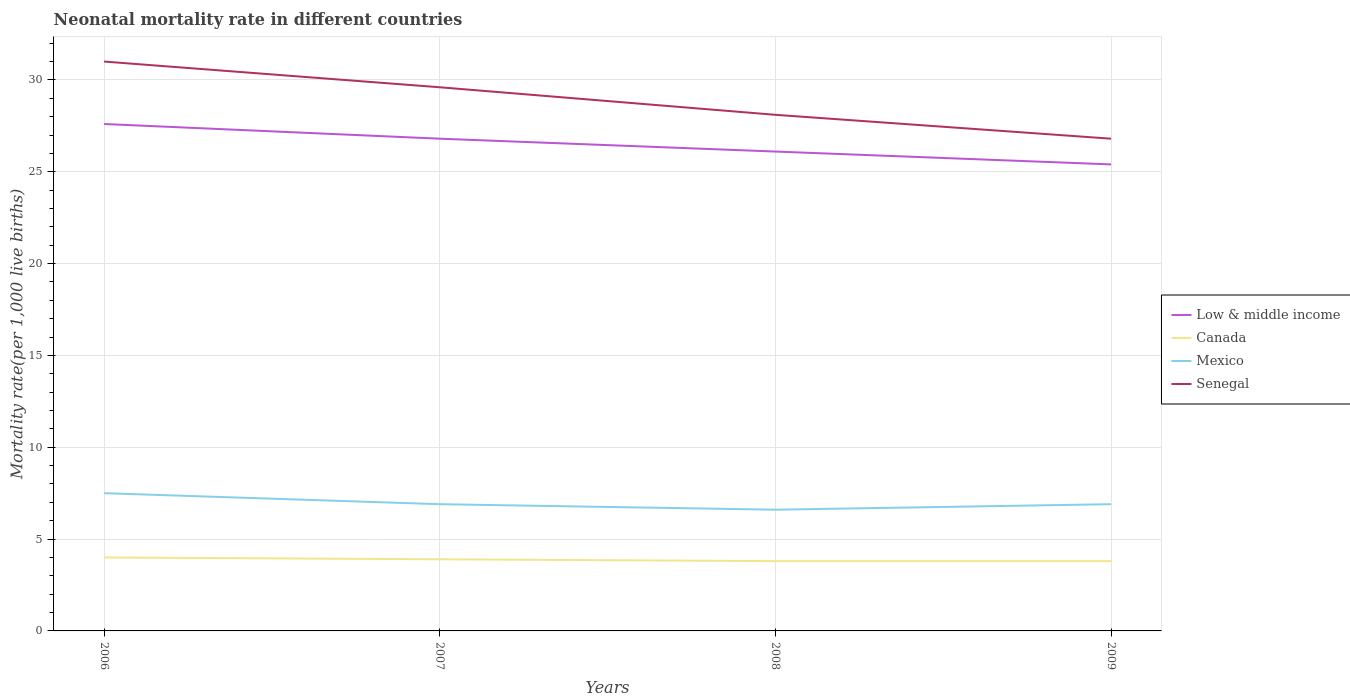Does the line corresponding to Canada intersect with the line corresponding to Senegal?
Provide a short and direct response. No. Across all years, what is the maximum neonatal mortality rate in Senegal?
Provide a short and direct response. 26.8. In which year was the neonatal mortality rate in Canada maximum?
Provide a succinct answer. 2008. What is the total neonatal mortality rate in Mexico in the graph?
Provide a succinct answer. 0.6. What is the difference between the highest and the second highest neonatal mortality rate in Canada?
Offer a terse response. 0.2. What is the difference between the highest and the lowest neonatal mortality rate in Mexico?
Provide a short and direct response. 1. How many years are there in the graph?
Keep it short and to the point. 4. What is the difference between two consecutive major ticks on the Y-axis?
Provide a short and direct response. 5. Does the graph contain any zero values?
Provide a succinct answer. No. How many legend labels are there?
Offer a terse response. 4. What is the title of the graph?
Offer a terse response. Neonatal mortality rate in different countries. Does "Kuwait" appear as one of the legend labels in the graph?
Ensure brevity in your answer.  No. What is the label or title of the X-axis?
Make the answer very short. Years. What is the label or title of the Y-axis?
Provide a short and direct response. Mortality rate(per 1,0 live births). What is the Mortality rate(per 1,000 live births) in Low & middle income in 2006?
Keep it short and to the point. 27.6. What is the Mortality rate(per 1,000 live births) of Mexico in 2006?
Give a very brief answer. 7.5. What is the Mortality rate(per 1,000 live births) of Senegal in 2006?
Provide a succinct answer. 31. What is the Mortality rate(per 1,000 live births) of Low & middle income in 2007?
Make the answer very short. 26.8. What is the Mortality rate(per 1,000 live births) of Senegal in 2007?
Your answer should be very brief. 29.6. What is the Mortality rate(per 1,000 live births) of Low & middle income in 2008?
Keep it short and to the point. 26.1. What is the Mortality rate(per 1,000 live births) in Canada in 2008?
Offer a very short reply. 3.8. What is the Mortality rate(per 1,000 live births) of Senegal in 2008?
Your answer should be very brief. 28.1. What is the Mortality rate(per 1,000 live births) of Low & middle income in 2009?
Make the answer very short. 25.4. What is the Mortality rate(per 1,000 live births) of Mexico in 2009?
Provide a short and direct response. 6.9. What is the Mortality rate(per 1,000 live births) in Senegal in 2009?
Give a very brief answer. 26.8. Across all years, what is the maximum Mortality rate(per 1,000 live births) in Low & middle income?
Provide a succinct answer. 27.6. Across all years, what is the maximum Mortality rate(per 1,000 live births) of Mexico?
Ensure brevity in your answer.  7.5. Across all years, what is the minimum Mortality rate(per 1,000 live births) of Low & middle income?
Your answer should be compact. 25.4. Across all years, what is the minimum Mortality rate(per 1,000 live births) in Senegal?
Ensure brevity in your answer.  26.8. What is the total Mortality rate(per 1,000 live births) in Low & middle income in the graph?
Keep it short and to the point. 105.9. What is the total Mortality rate(per 1,000 live births) of Canada in the graph?
Provide a succinct answer. 15.5. What is the total Mortality rate(per 1,000 live births) in Mexico in the graph?
Your answer should be compact. 27.9. What is the total Mortality rate(per 1,000 live births) in Senegal in the graph?
Ensure brevity in your answer.  115.5. What is the difference between the Mortality rate(per 1,000 live births) of Low & middle income in 2006 and that in 2007?
Keep it short and to the point. 0.8. What is the difference between the Mortality rate(per 1,000 live births) in Mexico in 2006 and that in 2007?
Give a very brief answer. 0.6. What is the difference between the Mortality rate(per 1,000 live births) in Canada in 2006 and that in 2008?
Offer a very short reply. 0.2. What is the difference between the Mortality rate(per 1,000 live births) in Mexico in 2006 and that in 2008?
Provide a succinct answer. 0.9. What is the difference between the Mortality rate(per 1,000 live births) in Senegal in 2006 and that in 2008?
Provide a short and direct response. 2.9. What is the difference between the Mortality rate(per 1,000 live births) of Low & middle income in 2006 and that in 2009?
Provide a succinct answer. 2.2. What is the difference between the Mortality rate(per 1,000 live births) of Mexico in 2006 and that in 2009?
Keep it short and to the point. 0.6. What is the difference between the Mortality rate(per 1,000 live births) in Senegal in 2006 and that in 2009?
Make the answer very short. 4.2. What is the difference between the Mortality rate(per 1,000 live births) in Low & middle income in 2007 and that in 2008?
Offer a very short reply. 0.7. What is the difference between the Mortality rate(per 1,000 live births) of Low & middle income in 2007 and that in 2009?
Ensure brevity in your answer.  1.4. What is the difference between the Mortality rate(per 1,000 live births) of Canada in 2007 and that in 2009?
Offer a terse response. 0.1. What is the difference between the Mortality rate(per 1,000 live births) of Senegal in 2007 and that in 2009?
Your answer should be compact. 2.8. What is the difference between the Mortality rate(per 1,000 live births) in Mexico in 2008 and that in 2009?
Keep it short and to the point. -0.3. What is the difference between the Mortality rate(per 1,000 live births) in Low & middle income in 2006 and the Mortality rate(per 1,000 live births) in Canada in 2007?
Your answer should be very brief. 23.7. What is the difference between the Mortality rate(per 1,000 live births) of Low & middle income in 2006 and the Mortality rate(per 1,000 live births) of Mexico in 2007?
Keep it short and to the point. 20.7. What is the difference between the Mortality rate(per 1,000 live births) in Low & middle income in 2006 and the Mortality rate(per 1,000 live births) in Senegal in 2007?
Your response must be concise. -2. What is the difference between the Mortality rate(per 1,000 live births) of Canada in 2006 and the Mortality rate(per 1,000 live births) of Senegal in 2007?
Offer a terse response. -25.6. What is the difference between the Mortality rate(per 1,000 live births) of Mexico in 2006 and the Mortality rate(per 1,000 live births) of Senegal in 2007?
Your response must be concise. -22.1. What is the difference between the Mortality rate(per 1,000 live births) in Low & middle income in 2006 and the Mortality rate(per 1,000 live births) in Canada in 2008?
Give a very brief answer. 23.8. What is the difference between the Mortality rate(per 1,000 live births) in Canada in 2006 and the Mortality rate(per 1,000 live births) in Mexico in 2008?
Your response must be concise. -2.6. What is the difference between the Mortality rate(per 1,000 live births) of Canada in 2006 and the Mortality rate(per 1,000 live births) of Senegal in 2008?
Give a very brief answer. -24.1. What is the difference between the Mortality rate(per 1,000 live births) in Mexico in 2006 and the Mortality rate(per 1,000 live births) in Senegal in 2008?
Your response must be concise. -20.6. What is the difference between the Mortality rate(per 1,000 live births) in Low & middle income in 2006 and the Mortality rate(per 1,000 live births) in Canada in 2009?
Provide a short and direct response. 23.8. What is the difference between the Mortality rate(per 1,000 live births) in Low & middle income in 2006 and the Mortality rate(per 1,000 live births) in Mexico in 2009?
Give a very brief answer. 20.7. What is the difference between the Mortality rate(per 1,000 live births) in Canada in 2006 and the Mortality rate(per 1,000 live births) in Mexico in 2009?
Offer a terse response. -2.9. What is the difference between the Mortality rate(per 1,000 live births) in Canada in 2006 and the Mortality rate(per 1,000 live births) in Senegal in 2009?
Keep it short and to the point. -22.8. What is the difference between the Mortality rate(per 1,000 live births) in Mexico in 2006 and the Mortality rate(per 1,000 live births) in Senegal in 2009?
Provide a short and direct response. -19.3. What is the difference between the Mortality rate(per 1,000 live births) of Low & middle income in 2007 and the Mortality rate(per 1,000 live births) of Mexico in 2008?
Offer a very short reply. 20.2. What is the difference between the Mortality rate(per 1,000 live births) of Canada in 2007 and the Mortality rate(per 1,000 live births) of Mexico in 2008?
Your answer should be compact. -2.7. What is the difference between the Mortality rate(per 1,000 live births) of Canada in 2007 and the Mortality rate(per 1,000 live births) of Senegal in 2008?
Make the answer very short. -24.2. What is the difference between the Mortality rate(per 1,000 live births) in Mexico in 2007 and the Mortality rate(per 1,000 live births) in Senegal in 2008?
Offer a terse response. -21.2. What is the difference between the Mortality rate(per 1,000 live births) in Low & middle income in 2007 and the Mortality rate(per 1,000 live births) in Canada in 2009?
Your response must be concise. 23. What is the difference between the Mortality rate(per 1,000 live births) in Low & middle income in 2007 and the Mortality rate(per 1,000 live births) in Senegal in 2009?
Give a very brief answer. 0. What is the difference between the Mortality rate(per 1,000 live births) in Canada in 2007 and the Mortality rate(per 1,000 live births) in Senegal in 2009?
Give a very brief answer. -22.9. What is the difference between the Mortality rate(per 1,000 live births) in Mexico in 2007 and the Mortality rate(per 1,000 live births) in Senegal in 2009?
Provide a short and direct response. -19.9. What is the difference between the Mortality rate(per 1,000 live births) of Low & middle income in 2008 and the Mortality rate(per 1,000 live births) of Canada in 2009?
Your response must be concise. 22.3. What is the difference between the Mortality rate(per 1,000 live births) in Low & middle income in 2008 and the Mortality rate(per 1,000 live births) in Senegal in 2009?
Make the answer very short. -0.7. What is the difference between the Mortality rate(per 1,000 live births) in Canada in 2008 and the Mortality rate(per 1,000 live births) in Senegal in 2009?
Your response must be concise. -23. What is the difference between the Mortality rate(per 1,000 live births) of Mexico in 2008 and the Mortality rate(per 1,000 live births) of Senegal in 2009?
Your answer should be very brief. -20.2. What is the average Mortality rate(per 1,000 live births) of Low & middle income per year?
Provide a short and direct response. 26.48. What is the average Mortality rate(per 1,000 live births) in Canada per year?
Offer a very short reply. 3.88. What is the average Mortality rate(per 1,000 live births) of Mexico per year?
Provide a succinct answer. 6.97. What is the average Mortality rate(per 1,000 live births) in Senegal per year?
Provide a short and direct response. 28.88. In the year 2006, what is the difference between the Mortality rate(per 1,000 live births) of Low & middle income and Mortality rate(per 1,000 live births) of Canada?
Offer a very short reply. 23.6. In the year 2006, what is the difference between the Mortality rate(per 1,000 live births) in Low & middle income and Mortality rate(per 1,000 live births) in Mexico?
Offer a very short reply. 20.1. In the year 2006, what is the difference between the Mortality rate(per 1,000 live births) of Low & middle income and Mortality rate(per 1,000 live births) of Senegal?
Ensure brevity in your answer.  -3.4. In the year 2006, what is the difference between the Mortality rate(per 1,000 live births) in Canada and Mortality rate(per 1,000 live births) in Mexico?
Make the answer very short. -3.5. In the year 2006, what is the difference between the Mortality rate(per 1,000 live births) in Mexico and Mortality rate(per 1,000 live births) in Senegal?
Provide a short and direct response. -23.5. In the year 2007, what is the difference between the Mortality rate(per 1,000 live births) in Low & middle income and Mortality rate(per 1,000 live births) in Canada?
Your answer should be very brief. 22.9. In the year 2007, what is the difference between the Mortality rate(per 1,000 live births) of Low & middle income and Mortality rate(per 1,000 live births) of Mexico?
Provide a short and direct response. 19.9. In the year 2007, what is the difference between the Mortality rate(per 1,000 live births) of Canada and Mortality rate(per 1,000 live births) of Senegal?
Provide a short and direct response. -25.7. In the year 2007, what is the difference between the Mortality rate(per 1,000 live births) of Mexico and Mortality rate(per 1,000 live births) of Senegal?
Offer a very short reply. -22.7. In the year 2008, what is the difference between the Mortality rate(per 1,000 live births) in Low & middle income and Mortality rate(per 1,000 live births) in Canada?
Your answer should be compact. 22.3. In the year 2008, what is the difference between the Mortality rate(per 1,000 live births) in Low & middle income and Mortality rate(per 1,000 live births) in Senegal?
Provide a short and direct response. -2. In the year 2008, what is the difference between the Mortality rate(per 1,000 live births) of Canada and Mortality rate(per 1,000 live births) of Mexico?
Provide a succinct answer. -2.8. In the year 2008, what is the difference between the Mortality rate(per 1,000 live births) of Canada and Mortality rate(per 1,000 live births) of Senegal?
Offer a very short reply. -24.3. In the year 2008, what is the difference between the Mortality rate(per 1,000 live births) of Mexico and Mortality rate(per 1,000 live births) of Senegal?
Keep it short and to the point. -21.5. In the year 2009, what is the difference between the Mortality rate(per 1,000 live births) of Low & middle income and Mortality rate(per 1,000 live births) of Canada?
Your answer should be compact. 21.6. In the year 2009, what is the difference between the Mortality rate(per 1,000 live births) in Low & middle income and Mortality rate(per 1,000 live births) in Mexico?
Your response must be concise. 18.5. In the year 2009, what is the difference between the Mortality rate(per 1,000 live births) in Canada and Mortality rate(per 1,000 live births) in Senegal?
Your answer should be compact. -23. In the year 2009, what is the difference between the Mortality rate(per 1,000 live births) of Mexico and Mortality rate(per 1,000 live births) of Senegal?
Make the answer very short. -19.9. What is the ratio of the Mortality rate(per 1,000 live births) of Low & middle income in 2006 to that in 2007?
Provide a succinct answer. 1.03. What is the ratio of the Mortality rate(per 1,000 live births) in Canada in 2006 to that in 2007?
Give a very brief answer. 1.03. What is the ratio of the Mortality rate(per 1,000 live births) of Mexico in 2006 to that in 2007?
Offer a very short reply. 1.09. What is the ratio of the Mortality rate(per 1,000 live births) in Senegal in 2006 to that in 2007?
Your answer should be compact. 1.05. What is the ratio of the Mortality rate(per 1,000 live births) of Low & middle income in 2006 to that in 2008?
Make the answer very short. 1.06. What is the ratio of the Mortality rate(per 1,000 live births) of Canada in 2006 to that in 2008?
Offer a very short reply. 1.05. What is the ratio of the Mortality rate(per 1,000 live births) in Mexico in 2006 to that in 2008?
Offer a very short reply. 1.14. What is the ratio of the Mortality rate(per 1,000 live births) in Senegal in 2006 to that in 2008?
Ensure brevity in your answer.  1.1. What is the ratio of the Mortality rate(per 1,000 live births) of Low & middle income in 2006 to that in 2009?
Provide a succinct answer. 1.09. What is the ratio of the Mortality rate(per 1,000 live births) in Canada in 2006 to that in 2009?
Keep it short and to the point. 1.05. What is the ratio of the Mortality rate(per 1,000 live births) in Mexico in 2006 to that in 2009?
Keep it short and to the point. 1.09. What is the ratio of the Mortality rate(per 1,000 live births) in Senegal in 2006 to that in 2009?
Your answer should be very brief. 1.16. What is the ratio of the Mortality rate(per 1,000 live births) of Low & middle income in 2007 to that in 2008?
Give a very brief answer. 1.03. What is the ratio of the Mortality rate(per 1,000 live births) of Canada in 2007 to that in 2008?
Keep it short and to the point. 1.03. What is the ratio of the Mortality rate(per 1,000 live births) of Mexico in 2007 to that in 2008?
Provide a short and direct response. 1.05. What is the ratio of the Mortality rate(per 1,000 live births) of Senegal in 2007 to that in 2008?
Your answer should be compact. 1.05. What is the ratio of the Mortality rate(per 1,000 live births) of Low & middle income in 2007 to that in 2009?
Provide a succinct answer. 1.06. What is the ratio of the Mortality rate(per 1,000 live births) in Canada in 2007 to that in 2009?
Ensure brevity in your answer.  1.03. What is the ratio of the Mortality rate(per 1,000 live births) of Mexico in 2007 to that in 2009?
Your response must be concise. 1. What is the ratio of the Mortality rate(per 1,000 live births) of Senegal in 2007 to that in 2009?
Your answer should be very brief. 1.1. What is the ratio of the Mortality rate(per 1,000 live births) of Low & middle income in 2008 to that in 2009?
Offer a very short reply. 1.03. What is the ratio of the Mortality rate(per 1,000 live births) of Mexico in 2008 to that in 2009?
Ensure brevity in your answer.  0.96. What is the ratio of the Mortality rate(per 1,000 live births) in Senegal in 2008 to that in 2009?
Ensure brevity in your answer.  1.05. What is the difference between the highest and the second highest Mortality rate(per 1,000 live births) of Low & middle income?
Your answer should be compact. 0.8. What is the difference between the highest and the second highest Mortality rate(per 1,000 live births) of Canada?
Your answer should be compact. 0.1. What is the difference between the highest and the second highest Mortality rate(per 1,000 live births) in Mexico?
Provide a succinct answer. 0.6. What is the difference between the highest and the lowest Mortality rate(per 1,000 live births) in Low & middle income?
Ensure brevity in your answer.  2.2. What is the difference between the highest and the lowest Mortality rate(per 1,000 live births) of Canada?
Your answer should be very brief. 0.2. 